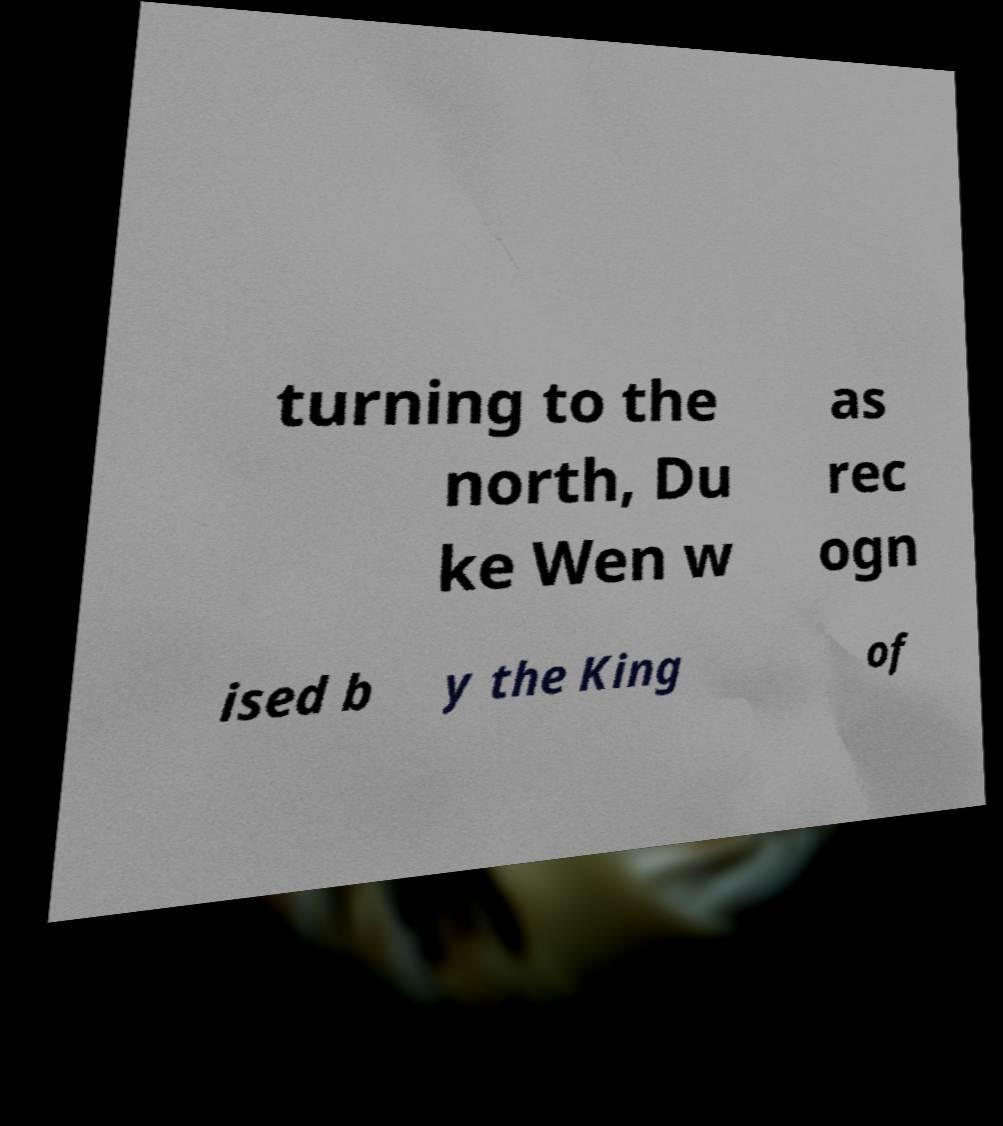Can you read and provide the text displayed in the image?This photo seems to have some interesting text. Can you extract and type it out for me? turning to the north, Du ke Wen w as rec ogn ised b y the King of 